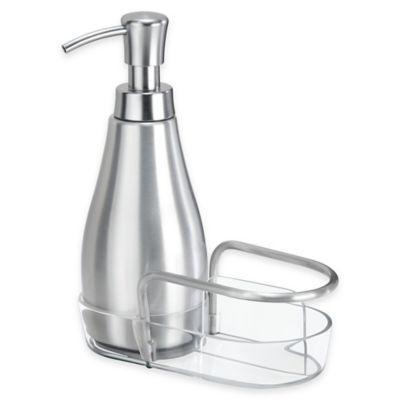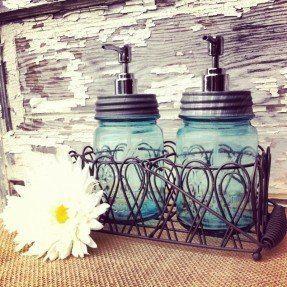The first image is the image on the left, the second image is the image on the right. Examine the images to the left and right. Is the description "None of the soap dispensers have stainless steel tops and at least two of the dispensers are made of clear glass." accurate? Answer yes or no. No. The first image is the image on the left, the second image is the image on the right. Assess this claim about the two images: "There are exactly three liquid soap dispenser pumps.". Correct or not? Answer yes or no. Yes. 